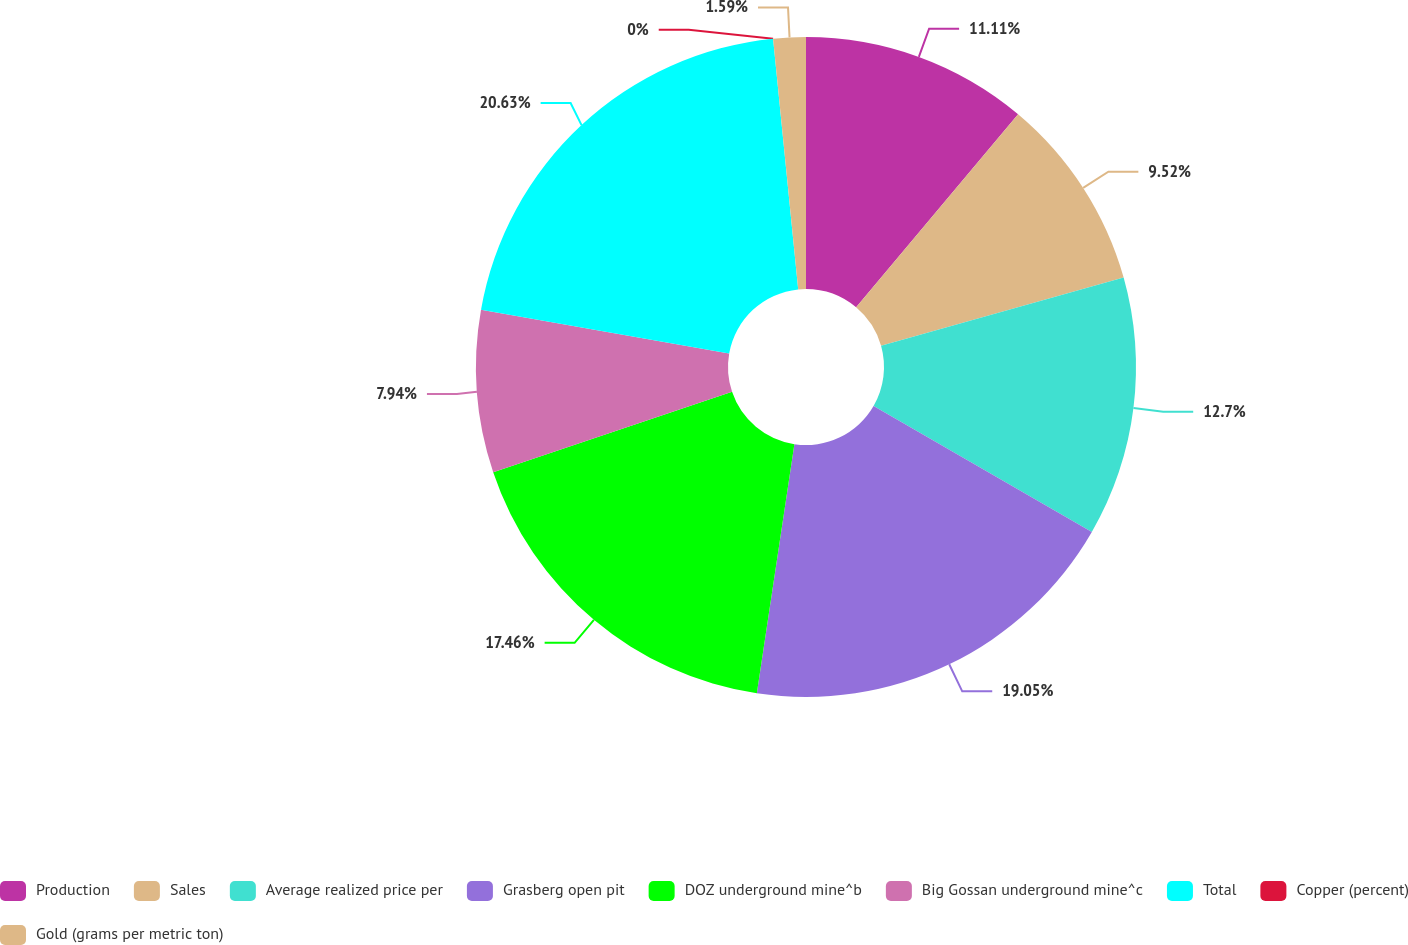Convert chart. <chart><loc_0><loc_0><loc_500><loc_500><pie_chart><fcel>Production<fcel>Sales<fcel>Average realized price per<fcel>Grasberg open pit<fcel>DOZ underground mine^b<fcel>Big Gossan underground mine^c<fcel>Total<fcel>Copper (percent)<fcel>Gold (grams per metric ton)<nl><fcel>11.11%<fcel>9.52%<fcel>12.7%<fcel>19.05%<fcel>17.46%<fcel>7.94%<fcel>20.63%<fcel>0.0%<fcel>1.59%<nl></chart> 